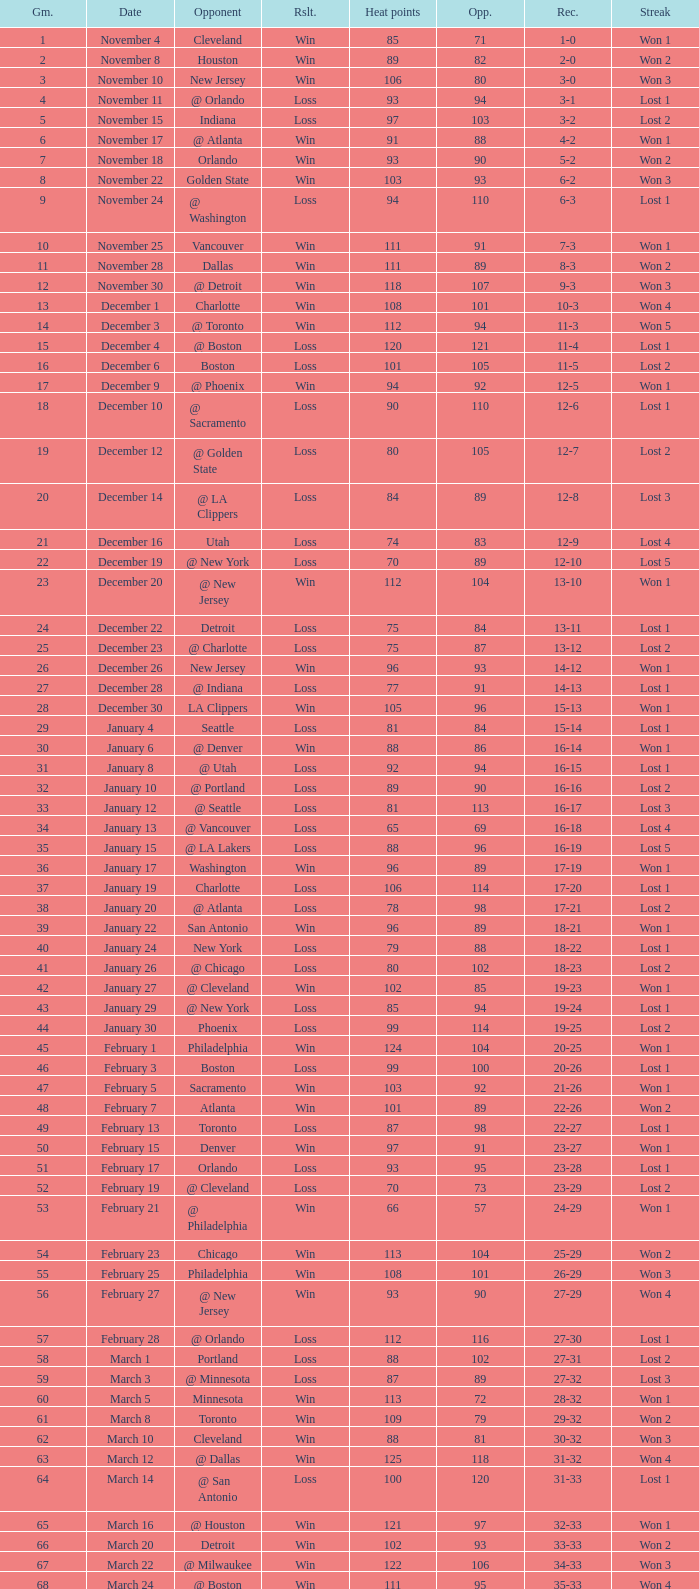What is Heat Points, when Game is less than 80, and when Date is "April 26 (First Round)"? 85.0. 